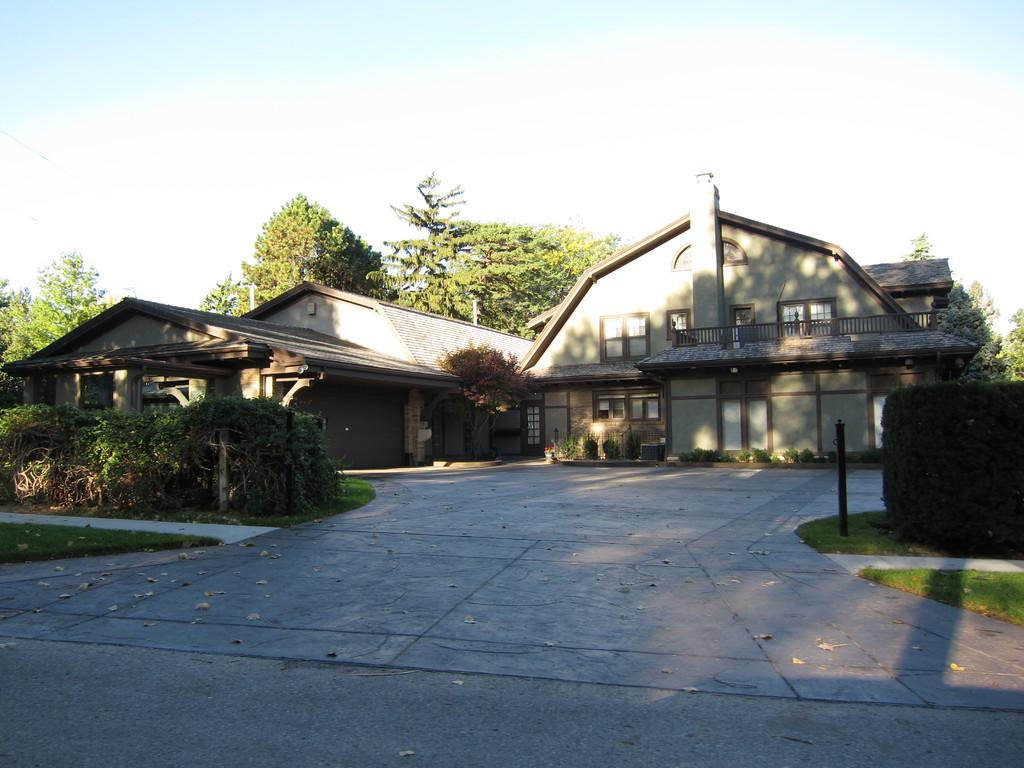What type of structure is visible in the image? There is a house in the image. What can be seen behind the house? There are trees behind the house. What is located in front of the house? There are plants and bushes in front of the house. Can you describe an object in front of the house? There is a metal rod in front of the house. Is there any blood visible on the house in the image? No, there is no blood visible on the house in the image. Can you see a coach parked in front of the house? No, there is no coach present in the image. 